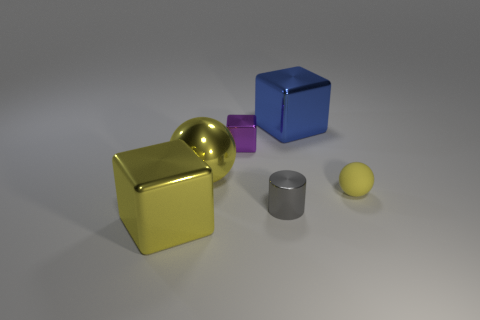The purple thing that is the same material as the gray thing is what size?
Keep it short and to the point. Small. What number of balls are either large yellow shiny objects or gray metal objects?
Your answer should be compact. 1. Are there more rubber spheres than big purple shiny cylinders?
Keep it short and to the point. Yes. How many yellow rubber spheres are the same size as the blue shiny thing?
Make the answer very short. 0. What shape is the tiny object that is the same color as the metal sphere?
Give a very brief answer. Sphere. What number of objects are large blue objects right of the cylinder or large yellow cubes?
Offer a very short reply. 2. Are there fewer yellow metal blocks than cubes?
Provide a succinct answer. Yes. What is the shape of the gray thing that is the same material as the big blue block?
Give a very brief answer. Cylinder. There is a matte ball; are there any yellow cubes right of it?
Provide a succinct answer. No. Are there fewer tiny yellow rubber objects that are left of the metallic cylinder than large yellow shiny balls?
Make the answer very short. Yes. 